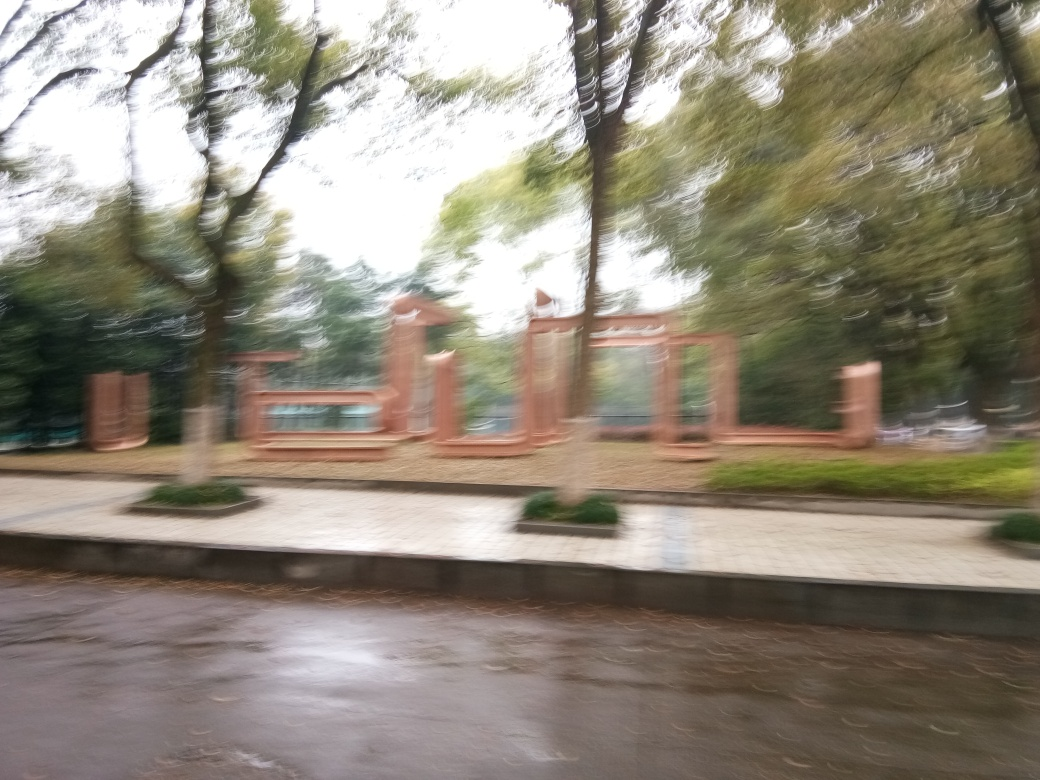What suggestions would you have for taking a better photo in a similar setting? To improve photo quality in a similar setting, one should ensure a steady hand or use a tripod to prevent camera shake. A higher shutter speed could also help avoid blur, and ensuring proper focus will result in a clearer picture. 